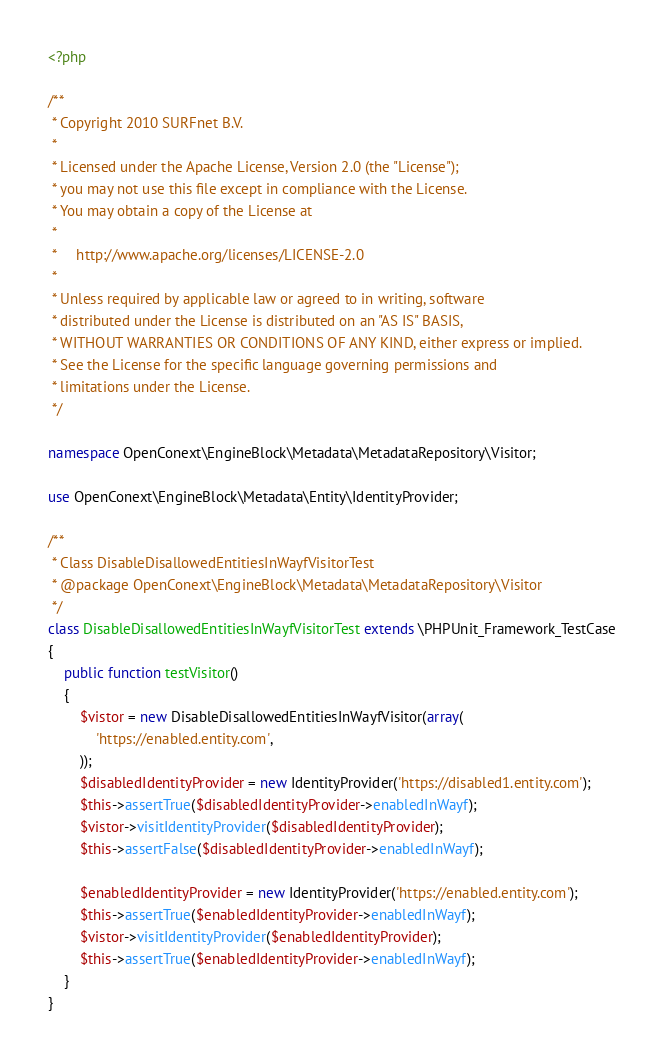Convert code to text. <code><loc_0><loc_0><loc_500><loc_500><_PHP_><?php

/**
 * Copyright 2010 SURFnet B.V.
 *
 * Licensed under the Apache License, Version 2.0 (the "License");
 * you may not use this file except in compliance with the License.
 * You may obtain a copy of the License at
 *
 *     http://www.apache.org/licenses/LICENSE-2.0
 *
 * Unless required by applicable law or agreed to in writing, software
 * distributed under the License is distributed on an "AS IS" BASIS,
 * WITHOUT WARRANTIES OR CONDITIONS OF ANY KIND, either express or implied.
 * See the License for the specific language governing permissions and
 * limitations under the License.
 */

namespace OpenConext\EngineBlock\Metadata\MetadataRepository\Visitor;

use OpenConext\EngineBlock\Metadata\Entity\IdentityProvider;

/**
 * Class DisableDisallowedEntitiesInWayfVisitorTest
 * @package OpenConext\EngineBlock\Metadata\MetadataRepository\Visitor
 */
class DisableDisallowedEntitiesInWayfVisitorTest extends \PHPUnit_Framework_TestCase
{
    public function testVisitor()
    {
        $vistor = new DisableDisallowedEntitiesInWayfVisitor(array(
            'https://enabled.entity.com',
        ));
        $disabledIdentityProvider = new IdentityProvider('https://disabled1.entity.com');
        $this->assertTrue($disabledIdentityProvider->enabledInWayf);
        $vistor->visitIdentityProvider($disabledIdentityProvider);
        $this->assertFalse($disabledIdentityProvider->enabledInWayf);

        $enabledIdentityProvider = new IdentityProvider('https://enabled.entity.com');
        $this->assertTrue($enabledIdentityProvider->enabledInWayf);
        $vistor->visitIdentityProvider($enabledIdentityProvider);
        $this->assertTrue($enabledIdentityProvider->enabledInWayf);
    }
}
</code> 